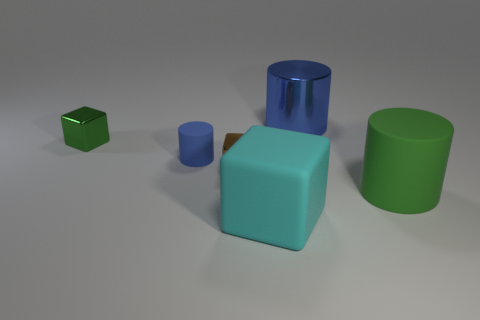How many metal blocks have the same color as the large shiny cylinder? 0 